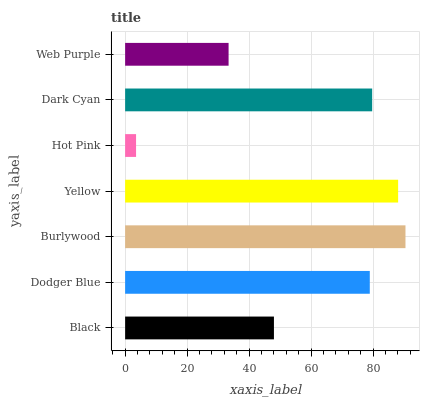Is Hot Pink the minimum?
Answer yes or no. Yes. Is Burlywood the maximum?
Answer yes or no. Yes. Is Dodger Blue the minimum?
Answer yes or no. No. Is Dodger Blue the maximum?
Answer yes or no. No. Is Dodger Blue greater than Black?
Answer yes or no. Yes. Is Black less than Dodger Blue?
Answer yes or no. Yes. Is Black greater than Dodger Blue?
Answer yes or no. No. Is Dodger Blue less than Black?
Answer yes or no. No. Is Dodger Blue the high median?
Answer yes or no. Yes. Is Dodger Blue the low median?
Answer yes or no. Yes. Is Dark Cyan the high median?
Answer yes or no. No. Is Web Purple the low median?
Answer yes or no. No. 